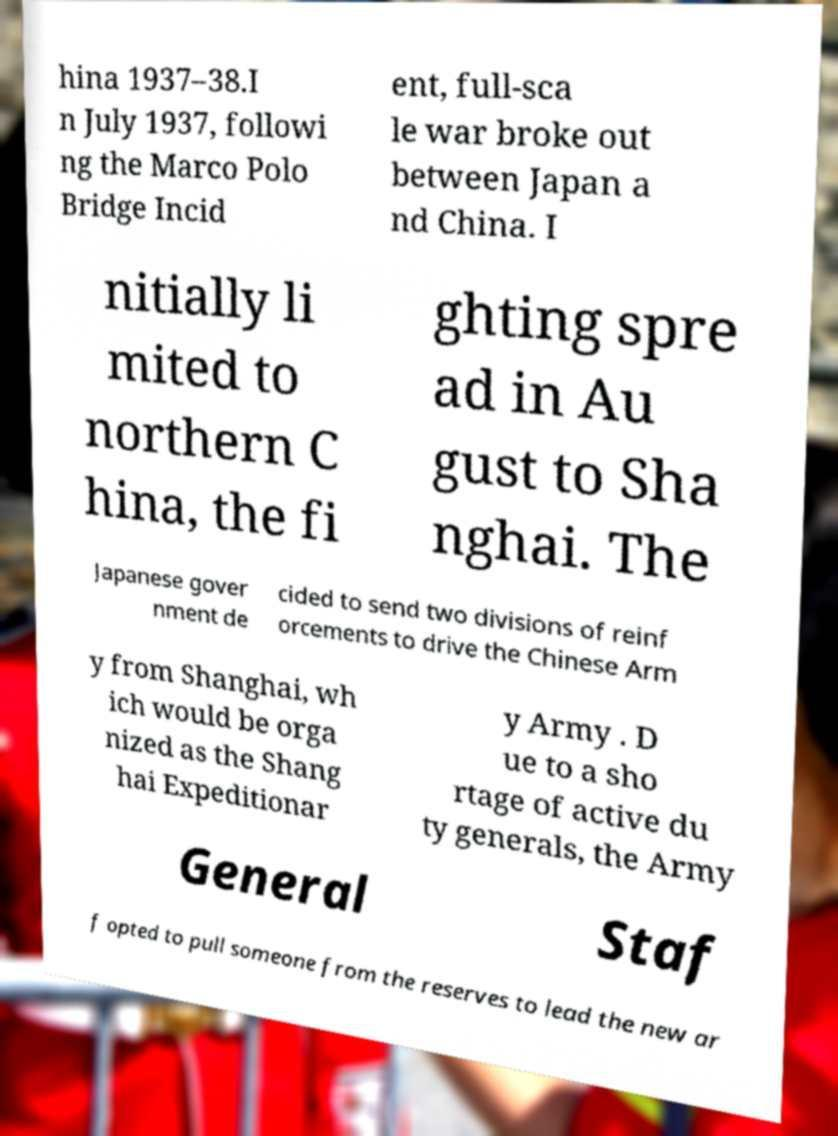Could you assist in decoding the text presented in this image and type it out clearly? hina 1937–38.I n July 1937, followi ng the Marco Polo Bridge Incid ent, full-sca le war broke out between Japan a nd China. I nitially li mited to northern C hina, the fi ghting spre ad in Au gust to Sha nghai. The Japanese gover nment de cided to send two divisions of reinf orcements to drive the Chinese Arm y from Shanghai, wh ich would be orga nized as the Shang hai Expeditionar y Army . D ue to a sho rtage of active du ty generals, the Army General Staf f opted to pull someone from the reserves to lead the new ar 